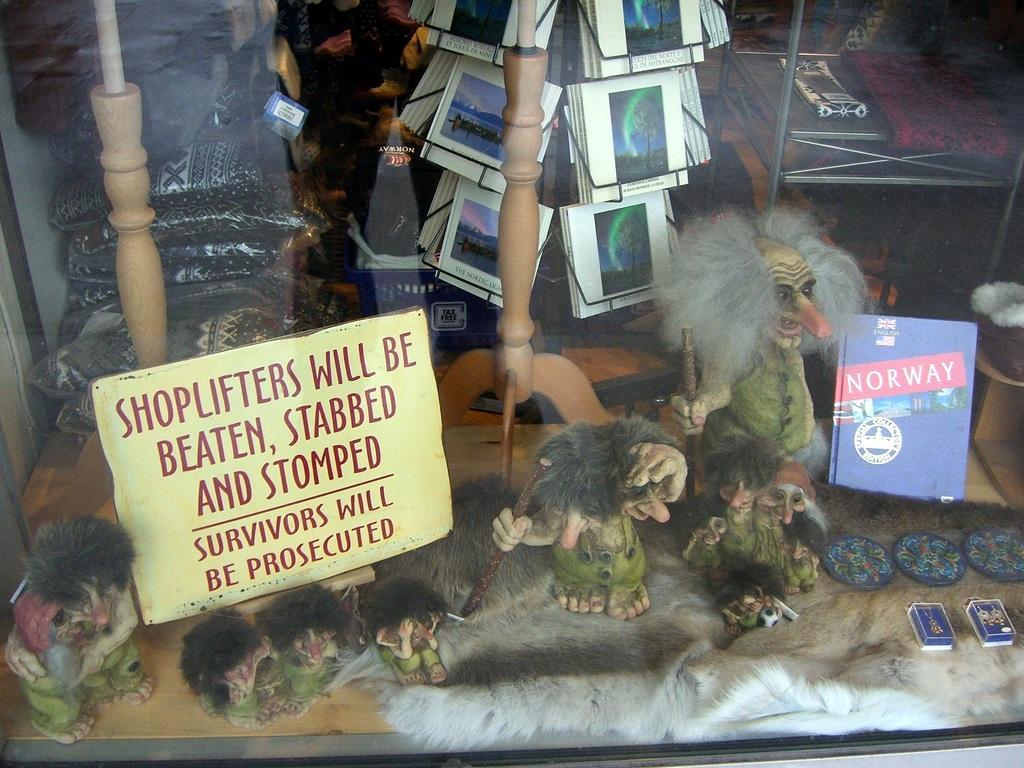Provide a one-sentence caption for the provided image. A window display with a warning to shoplifters saying they will be beaten. 